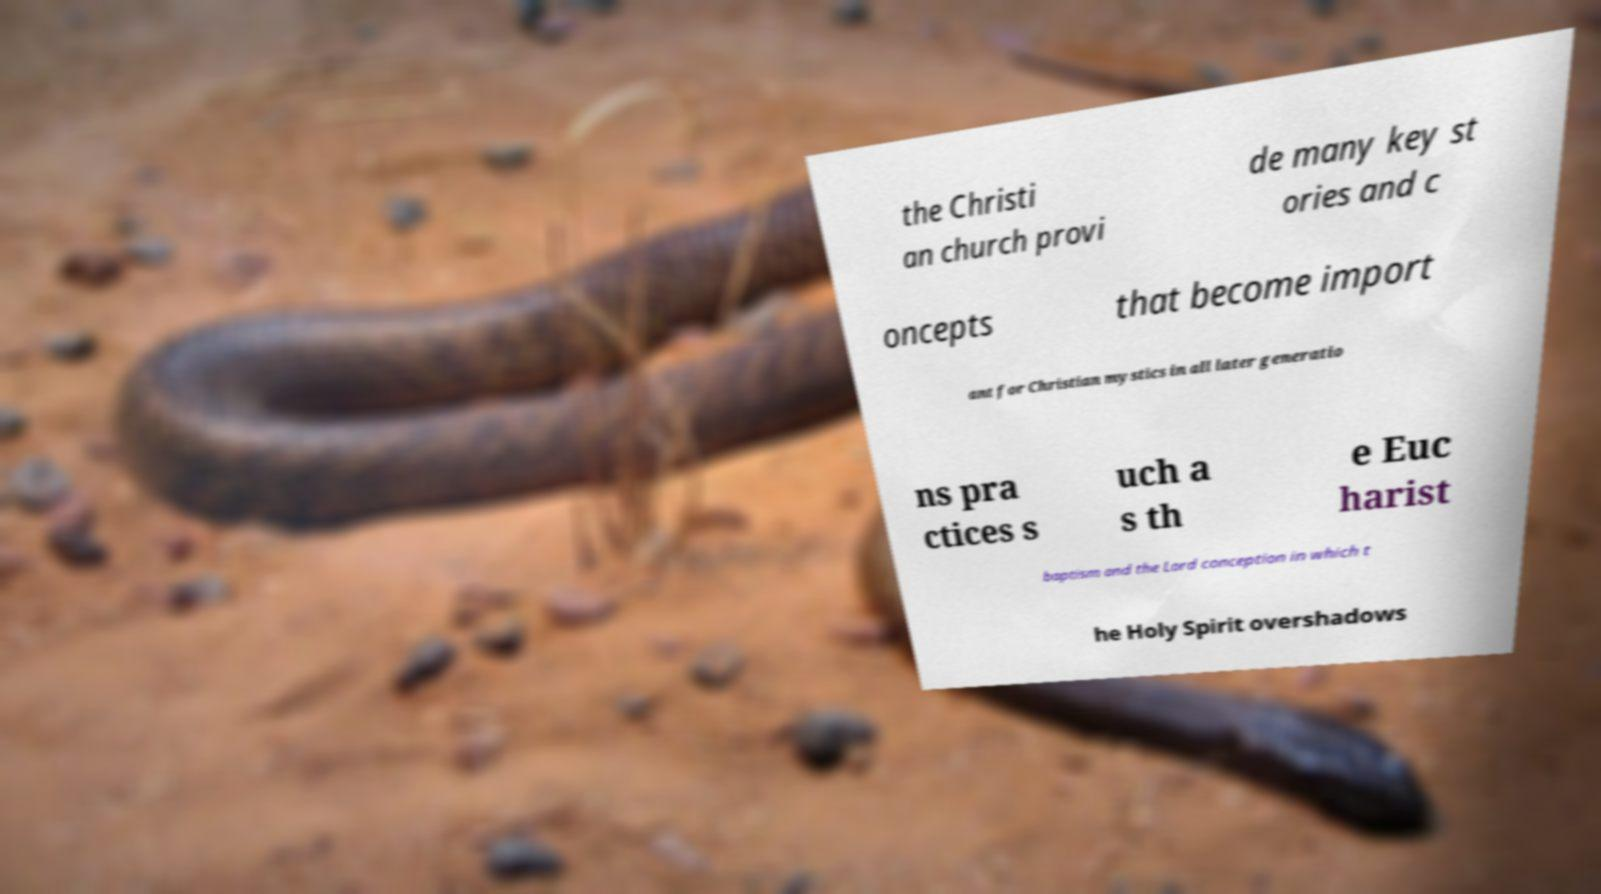For documentation purposes, I need the text within this image transcribed. Could you provide that? the Christi an church provi de many key st ories and c oncepts that become import ant for Christian mystics in all later generatio ns pra ctices s uch a s th e Euc harist baptism and the Lord conception in which t he Holy Spirit overshadows 